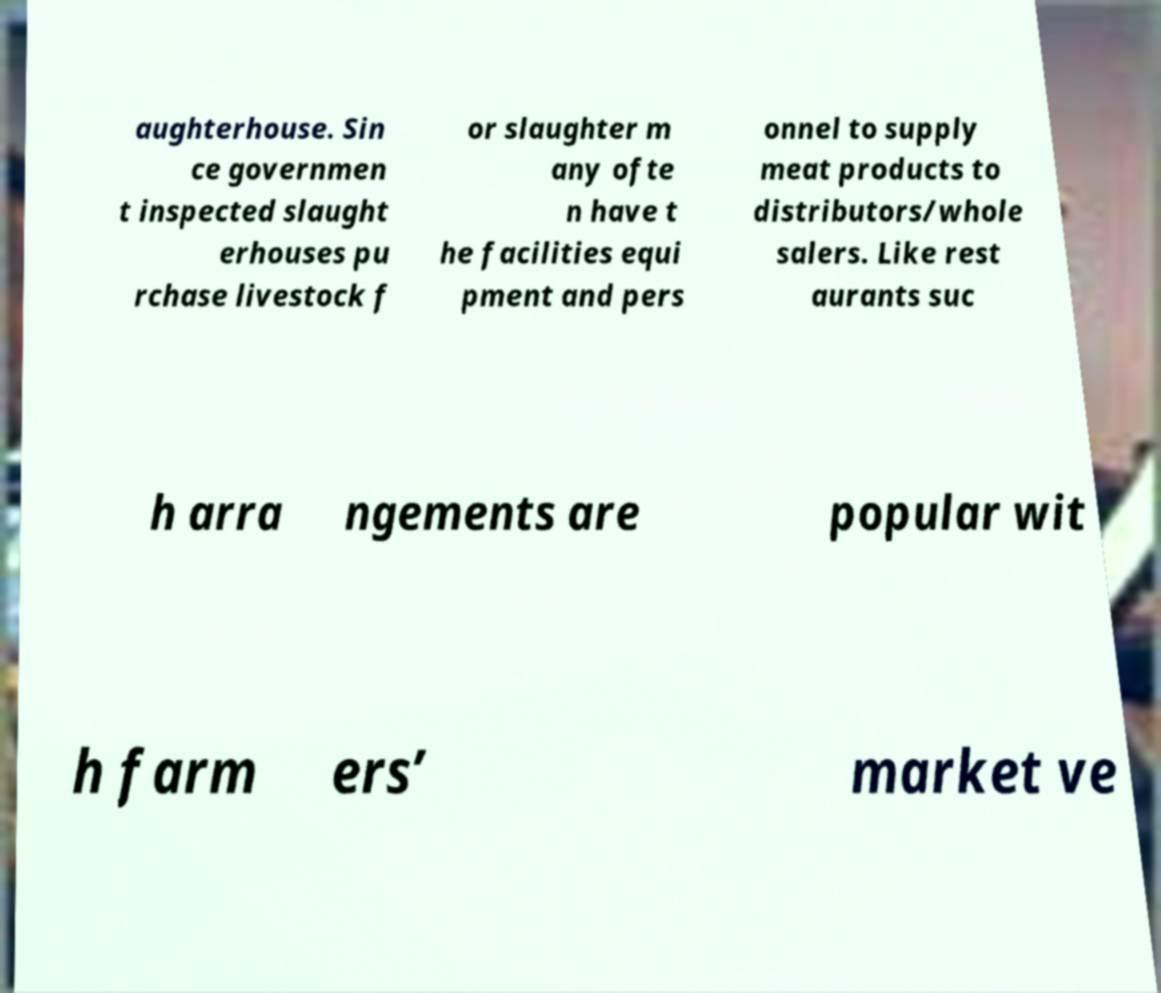Can you read and provide the text displayed in the image?This photo seems to have some interesting text. Can you extract and type it out for me? aughterhouse. Sin ce governmen t inspected slaught erhouses pu rchase livestock f or slaughter m any ofte n have t he facilities equi pment and pers onnel to supply meat products to distributors/whole salers. Like rest aurants suc h arra ngements are popular wit h farm ers’ market ve 